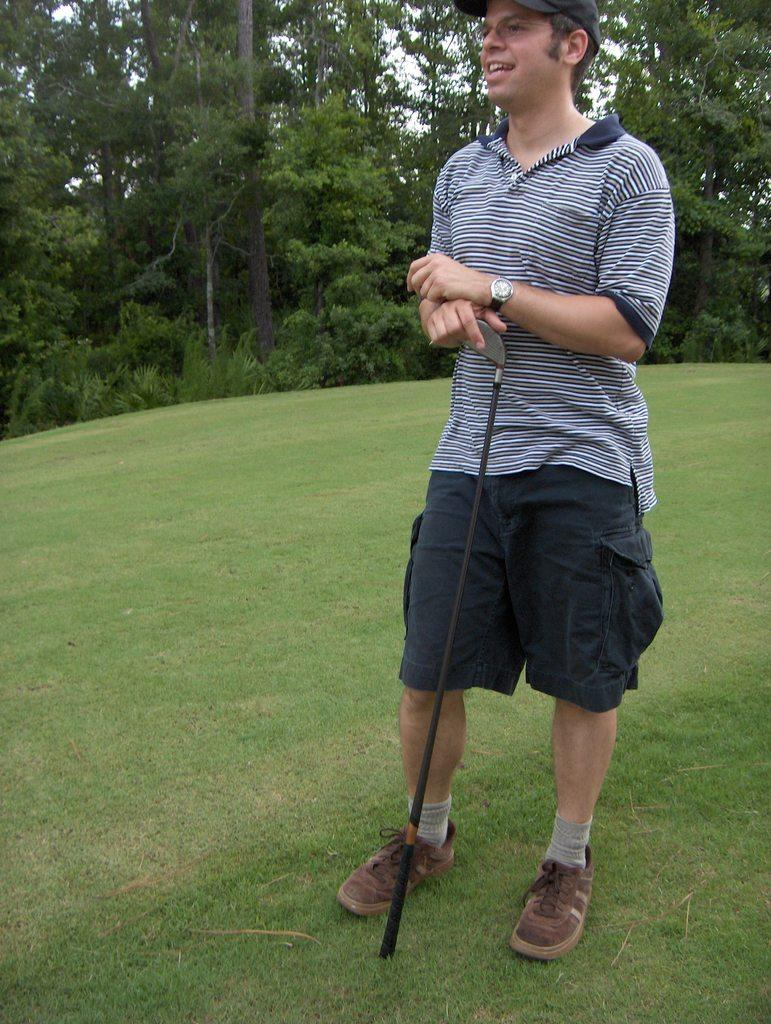Who is present in the image? There is a man in the image. What is the man wearing? The man is wearing a blue t-shirt and shorts. Where is the man located? The man is standing in a golf ground. What is the man holding? The man is holding a golf stick. What can be seen in the background of the image? There are many trees in the background of the image. What type of shop can be seen in the image? There is no shop present in the image; it features a man playing golf in a golf ground. 